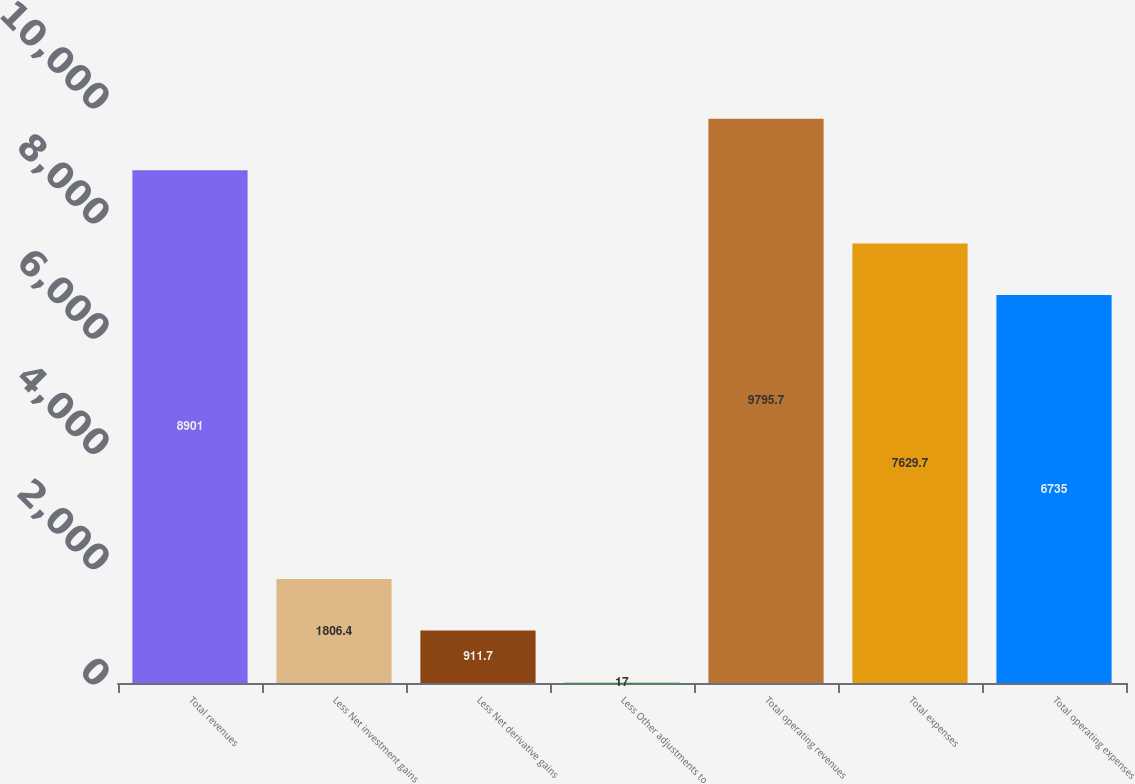Convert chart. <chart><loc_0><loc_0><loc_500><loc_500><bar_chart><fcel>Total revenues<fcel>Less Net investment gains<fcel>Less Net derivative gains<fcel>Less Other adjustments to<fcel>Total operating revenues<fcel>Total expenses<fcel>Total operating expenses<nl><fcel>8901<fcel>1806.4<fcel>911.7<fcel>17<fcel>9795.7<fcel>7629.7<fcel>6735<nl></chart> 